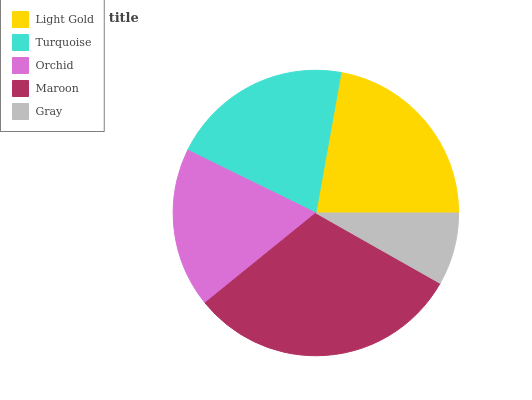Is Gray the minimum?
Answer yes or no. Yes. Is Maroon the maximum?
Answer yes or no. Yes. Is Turquoise the minimum?
Answer yes or no. No. Is Turquoise the maximum?
Answer yes or no. No. Is Light Gold greater than Turquoise?
Answer yes or no. Yes. Is Turquoise less than Light Gold?
Answer yes or no. Yes. Is Turquoise greater than Light Gold?
Answer yes or no. No. Is Light Gold less than Turquoise?
Answer yes or no. No. Is Turquoise the high median?
Answer yes or no. Yes. Is Turquoise the low median?
Answer yes or no. Yes. Is Maroon the high median?
Answer yes or no. No. Is Gray the low median?
Answer yes or no. No. 